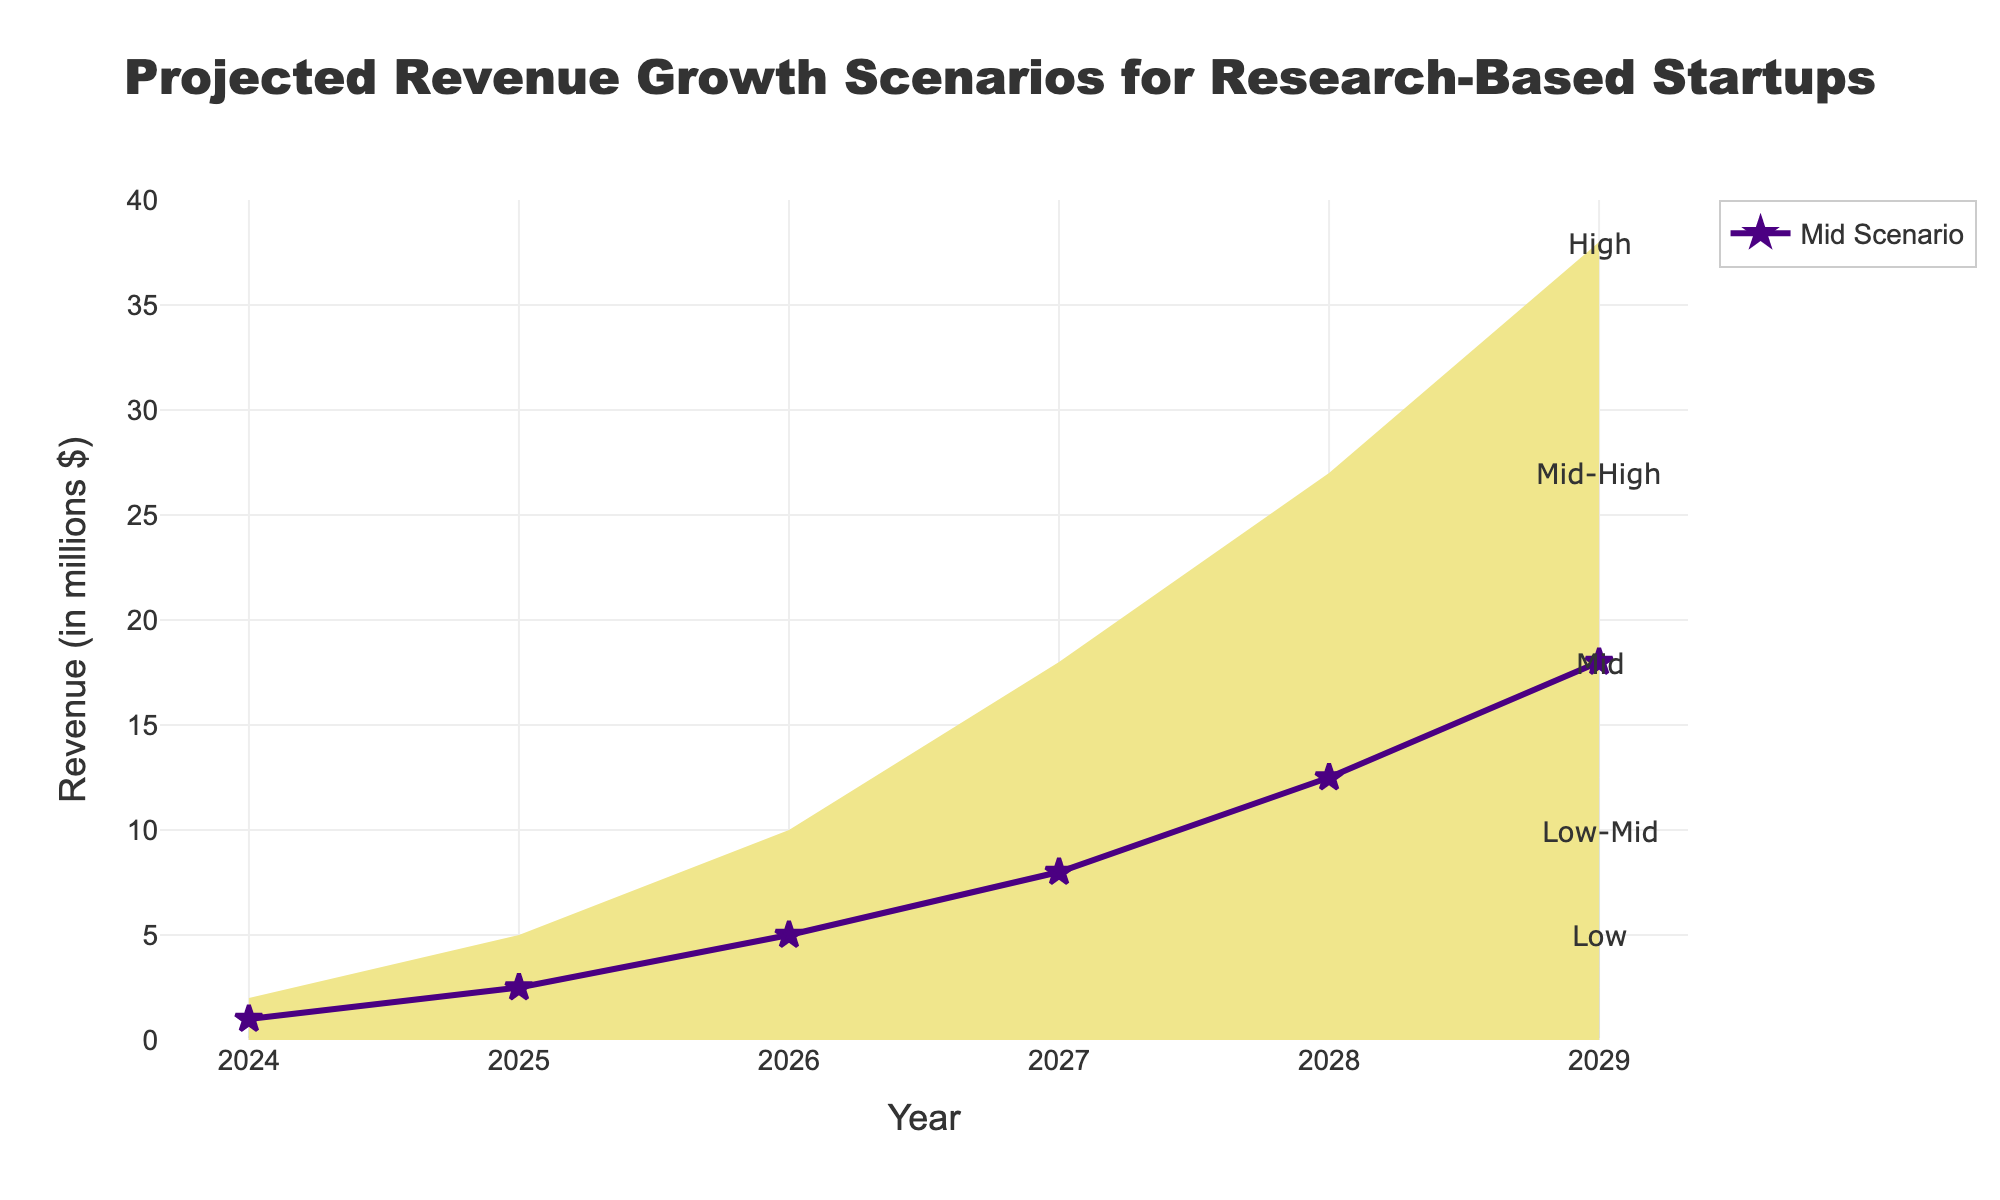What is the title of the figure? The title of the figure is prominently displayed at the top and reads "Projected Revenue Growth Scenarios for Research-Based Startups"
Answer: Projected Revenue Growth Scenarios for Research-Based Startups What time period does this fan chart cover? The x-axis represents the years, with the data ranging from 2024 to 2029
Answer: 2024 to 2029 What is the range of revenue for the 'High' scenario in 2029? The annotations and y-axis detail that the revenue range for the 'High' scenario in 2029 can reach up to $38 million
Answer: $38 million Which scenario is represented by a line with a purple color? The visual representation in the figure shows that the 'Mid' scenario is marked by a purple line with star markers
Answer: Mid How does the projected revenue in the 'Low' scenario change from 2024 to 2029? By observing the 'Low' scenario in the filled area, revenue increases from $0.2 million in 2024 to $5 million in 2029
Answer: From $0.2 million to $5 million What is the average projected revenue for the 'Mid-High' scenario between 2026 and 2028? To find the average, sum the values for 2026 (7.5), 2027 (12.5), and 2028 (19.0), then divide by 3: (7.5 + 12.5 + 19.0) / 3 = 13.0 million
Answer: 13.0 million In which year does the 'Mid' scenario first project a revenue of at least $8 million? By examining the figure, the 'Mid' scenario reaches $8 million in 2027
Answer: 2027 How do the uncertainties (range between 'Low' and 'High' scenarios) in projected revenue change from 2024 to 2029? The range between 'Low' and 'High' scenarios broadens from 2024 ($0.2 million to $2 million) to 2029 ($5 million to $38 million), indicating increased uncertainty over time
Answer: It broadens over time Which two scenarios show the closest revenue projections in 2025? Observing the figure, the 'Low-Mid' and 'Mid' scenarios in 2025 are closest, showing $1.2 million and $2.5 million respectively, both relatively close compared to others
Answer: Low-Mid and Mid What is the total projected revenue increase for the 'High' scenario from 2024 to 2029? Subtracting the beginning value in 2024 ($2 million) from the end value in 2029 ($38 million) gives an increase of $36 million
Answer: $36 million 